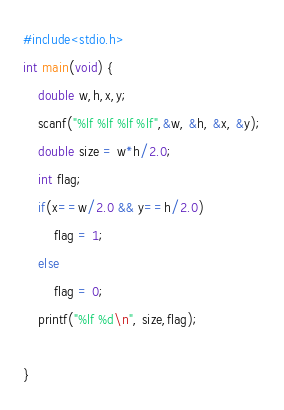Convert code to text. <code><loc_0><loc_0><loc_500><loc_500><_C_>#include<stdio.h>
int main(void) {
    double w,h,x,y;
    scanf("%lf %lf %lf %lf",&w, &h, &x, &y);
    double size = w*h/2.0;
    int flag;
    if(x==w/2.0 && y==h/2.0)
        flag = 1;
    else
        flag = 0;
    printf("%lf %d\n", size,flag);

}</code> 